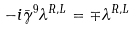<formula> <loc_0><loc_0><loc_500><loc_500>- i \bar { \gamma } ^ { 9 } \lambda ^ { R , L } = \mp \lambda ^ { R , L }</formula> 